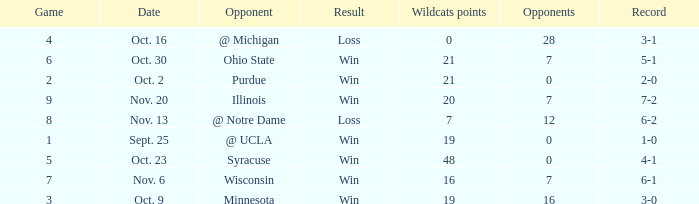What is the lowest points scored by the Wildcats when the record was 5-1? 21.0. 